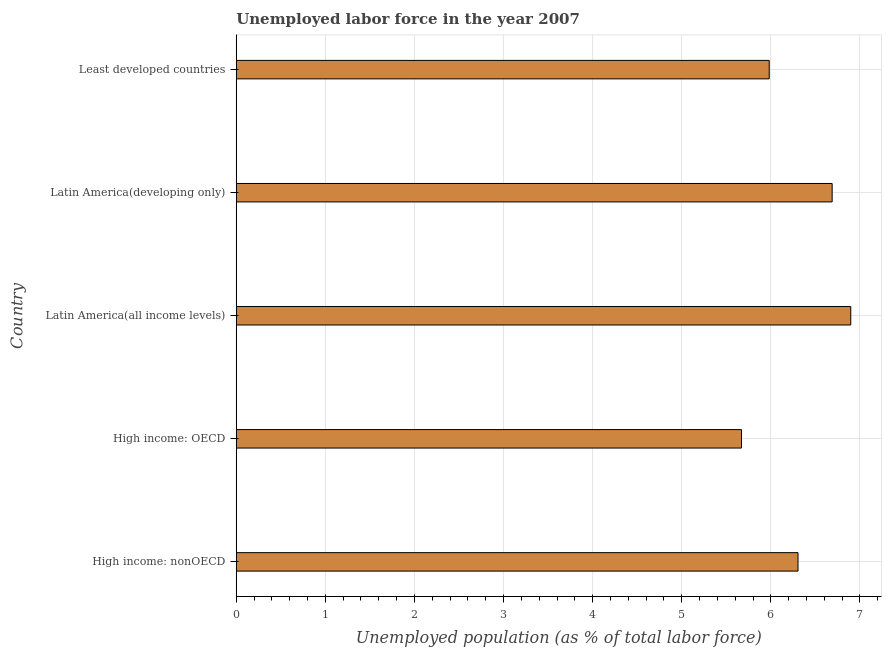What is the title of the graph?
Your answer should be very brief. Unemployed labor force in the year 2007. What is the label or title of the X-axis?
Your answer should be compact. Unemployed population (as % of total labor force). What is the total unemployed population in Latin America(all income levels)?
Give a very brief answer. 6.9. Across all countries, what is the maximum total unemployed population?
Offer a very short reply. 6.9. Across all countries, what is the minimum total unemployed population?
Provide a succinct answer. 5.67. In which country was the total unemployed population maximum?
Offer a very short reply. Latin America(all income levels). In which country was the total unemployed population minimum?
Your answer should be very brief. High income: OECD. What is the sum of the total unemployed population?
Keep it short and to the point. 31.54. What is the difference between the total unemployed population in High income: nonOECD and Least developed countries?
Provide a succinct answer. 0.32. What is the average total unemployed population per country?
Offer a terse response. 6.31. What is the median total unemployed population?
Offer a very short reply. 6.31. What is the ratio of the total unemployed population in High income: OECD to that in Least developed countries?
Provide a short and direct response. 0.95. Is the difference between the total unemployed population in High income: OECD and Least developed countries greater than the difference between any two countries?
Provide a succinct answer. No. What is the difference between the highest and the second highest total unemployed population?
Your response must be concise. 0.21. What is the difference between the highest and the lowest total unemployed population?
Your answer should be very brief. 1.23. How many bars are there?
Your response must be concise. 5. How many countries are there in the graph?
Ensure brevity in your answer.  5. Are the values on the major ticks of X-axis written in scientific E-notation?
Make the answer very short. No. What is the Unemployed population (as % of total labor force) in High income: nonOECD?
Your answer should be very brief. 6.31. What is the Unemployed population (as % of total labor force) in High income: OECD?
Provide a succinct answer. 5.67. What is the Unemployed population (as % of total labor force) in Latin America(all income levels)?
Your answer should be very brief. 6.9. What is the Unemployed population (as % of total labor force) of Latin America(developing only)?
Keep it short and to the point. 6.69. What is the Unemployed population (as % of total labor force) of Least developed countries?
Your response must be concise. 5.98. What is the difference between the Unemployed population (as % of total labor force) in High income: nonOECD and High income: OECD?
Offer a terse response. 0.63. What is the difference between the Unemployed population (as % of total labor force) in High income: nonOECD and Latin America(all income levels)?
Your answer should be compact. -0.59. What is the difference between the Unemployed population (as % of total labor force) in High income: nonOECD and Latin America(developing only)?
Provide a succinct answer. -0.38. What is the difference between the Unemployed population (as % of total labor force) in High income: nonOECD and Least developed countries?
Provide a succinct answer. 0.32. What is the difference between the Unemployed population (as % of total labor force) in High income: OECD and Latin America(all income levels)?
Give a very brief answer. -1.23. What is the difference between the Unemployed population (as % of total labor force) in High income: OECD and Latin America(developing only)?
Offer a very short reply. -1.02. What is the difference between the Unemployed population (as % of total labor force) in High income: OECD and Least developed countries?
Offer a terse response. -0.31. What is the difference between the Unemployed population (as % of total labor force) in Latin America(all income levels) and Latin America(developing only)?
Provide a succinct answer. 0.21. What is the difference between the Unemployed population (as % of total labor force) in Latin America(all income levels) and Least developed countries?
Make the answer very short. 0.92. What is the difference between the Unemployed population (as % of total labor force) in Latin America(developing only) and Least developed countries?
Give a very brief answer. 0.71. What is the ratio of the Unemployed population (as % of total labor force) in High income: nonOECD to that in High income: OECD?
Provide a short and direct response. 1.11. What is the ratio of the Unemployed population (as % of total labor force) in High income: nonOECD to that in Latin America(all income levels)?
Provide a succinct answer. 0.91. What is the ratio of the Unemployed population (as % of total labor force) in High income: nonOECD to that in Latin America(developing only)?
Your response must be concise. 0.94. What is the ratio of the Unemployed population (as % of total labor force) in High income: nonOECD to that in Least developed countries?
Make the answer very short. 1.05. What is the ratio of the Unemployed population (as % of total labor force) in High income: OECD to that in Latin America(all income levels)?
Offer a very short reply. 0.82. What is the ratio of the Unemployed population (as % of total labor force) in High income: OECD to that in Latin America(developing only)?
Offer a terse response. 0.85. What is the ratio of the Unemployed population (as % of total labor force) in High income: OECD to that in Least developed countries?
Keep it short and to the point. 0.95. What is the ratio of the Unemployed population (as % of total labor force) in Latin America(all income levels) to that in Latin America(developing only)?
Ensure brevity in your answer.  1.03. What is the ratio of the Unemployed population (as % of total labor force) in Latin America(all income levels) to that in Least developed countries?
Make the answer very short. 1.15. What is the ratio of the Unemployed population (as % of total labor force) in Latin America(developing only) to that in Least developed countries?
Offer a terse response. 1.12. 